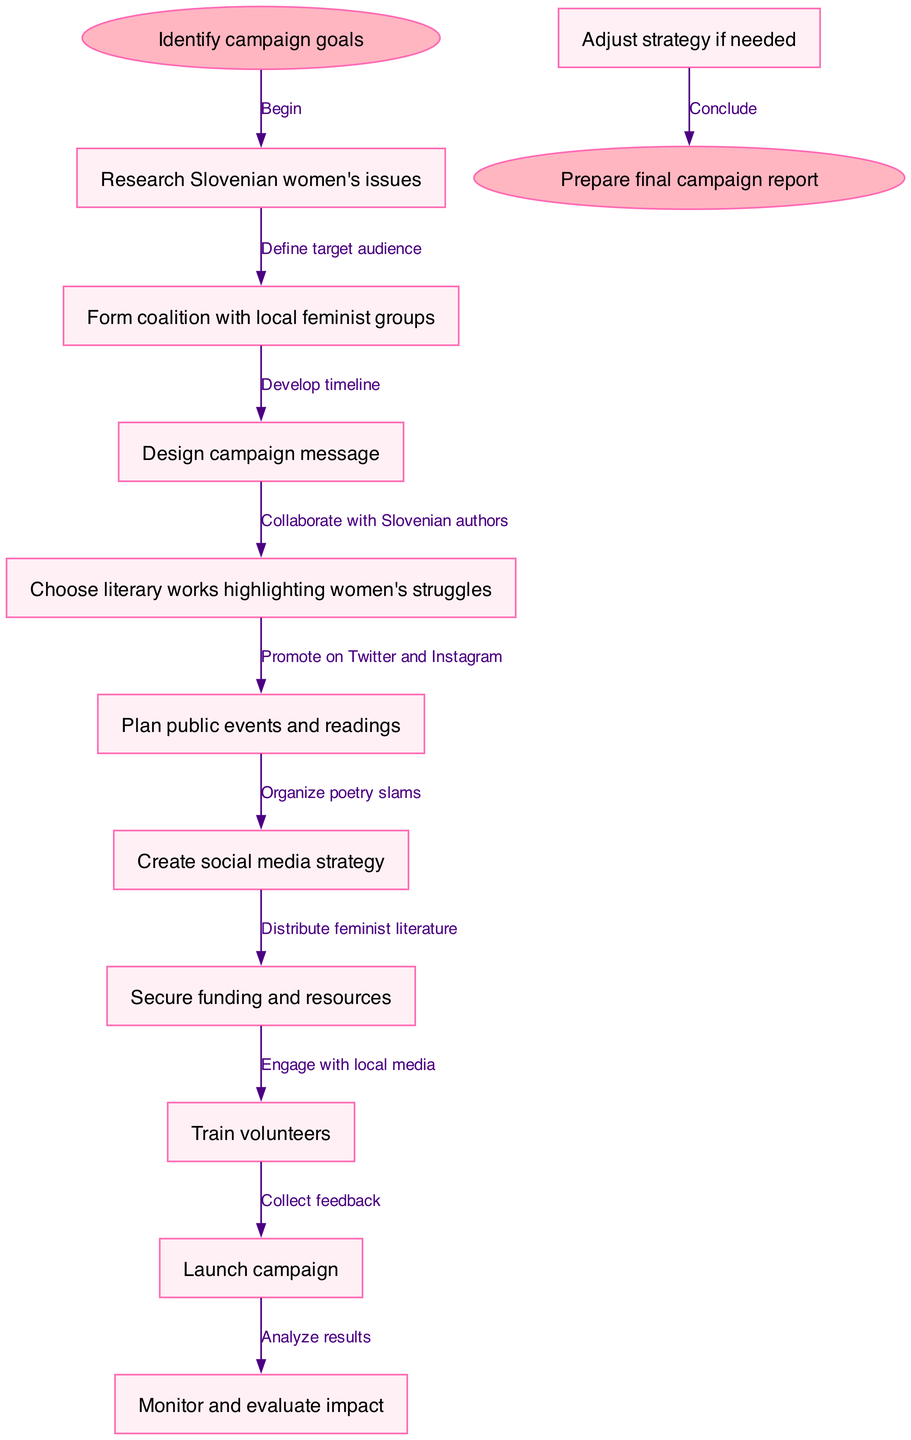What is the starting point of the campaign? The diagram indicates that the starting point is labeled as "Identify campaign goals." This is the first node that initiates the flow of the campaign planning process.
Answer: Identify campaign goals How many nodes are there in total? The diagram consists of 11 nodes: 1 starting node, 9 campaign steps, and 1 end node. Counting all the nodes results in a total of 11.
Answer: 11 What is the last step before concluding the campaign? The last step before concluding the campaign is "Adjust strategy if needed," which is the final node in the flow of campaign execution before heading to the end node.
Answer: Adjust strategy if needed Which type of events are planned to promote the campaign? The diagram specifies "Organize poetry slams" as one type of event planned to promote the campaign, indicating an engagement with artistic expression as a means of awareness.
Answer: Organize poetry slams How does the campaign begin? According to the diagram, the campaign begins with an edge labeled "Begin" connecting the starting node to the first node, which signifies the initiation of all planned actions.
Answer: Begin What is one method for engaging the audience highlighted in the diagram? The diagram includes "Promote on Twitter and Instagram" as one method for engaging with the target audience, showcasing the use of social media in the campaign strategy.
Answer: Promote on Twitter and Instagram Which node involves collaborations? The diagram shows "Collaborate with Slovenian authors" as an edge, connecting tasks in the process that specifically indicates the collaboration aspect related to literature in the campaign.
Answer: Collaborate with Slovenian authors What is the goal of the final report mentioned in the diagram? The final report's goal is to summarize the outcomes and learnings from the campaign planning and execution process, culminating in the preparation of the final campaign report at the end of the flowchart.
Answer: Prepare final campaign report 